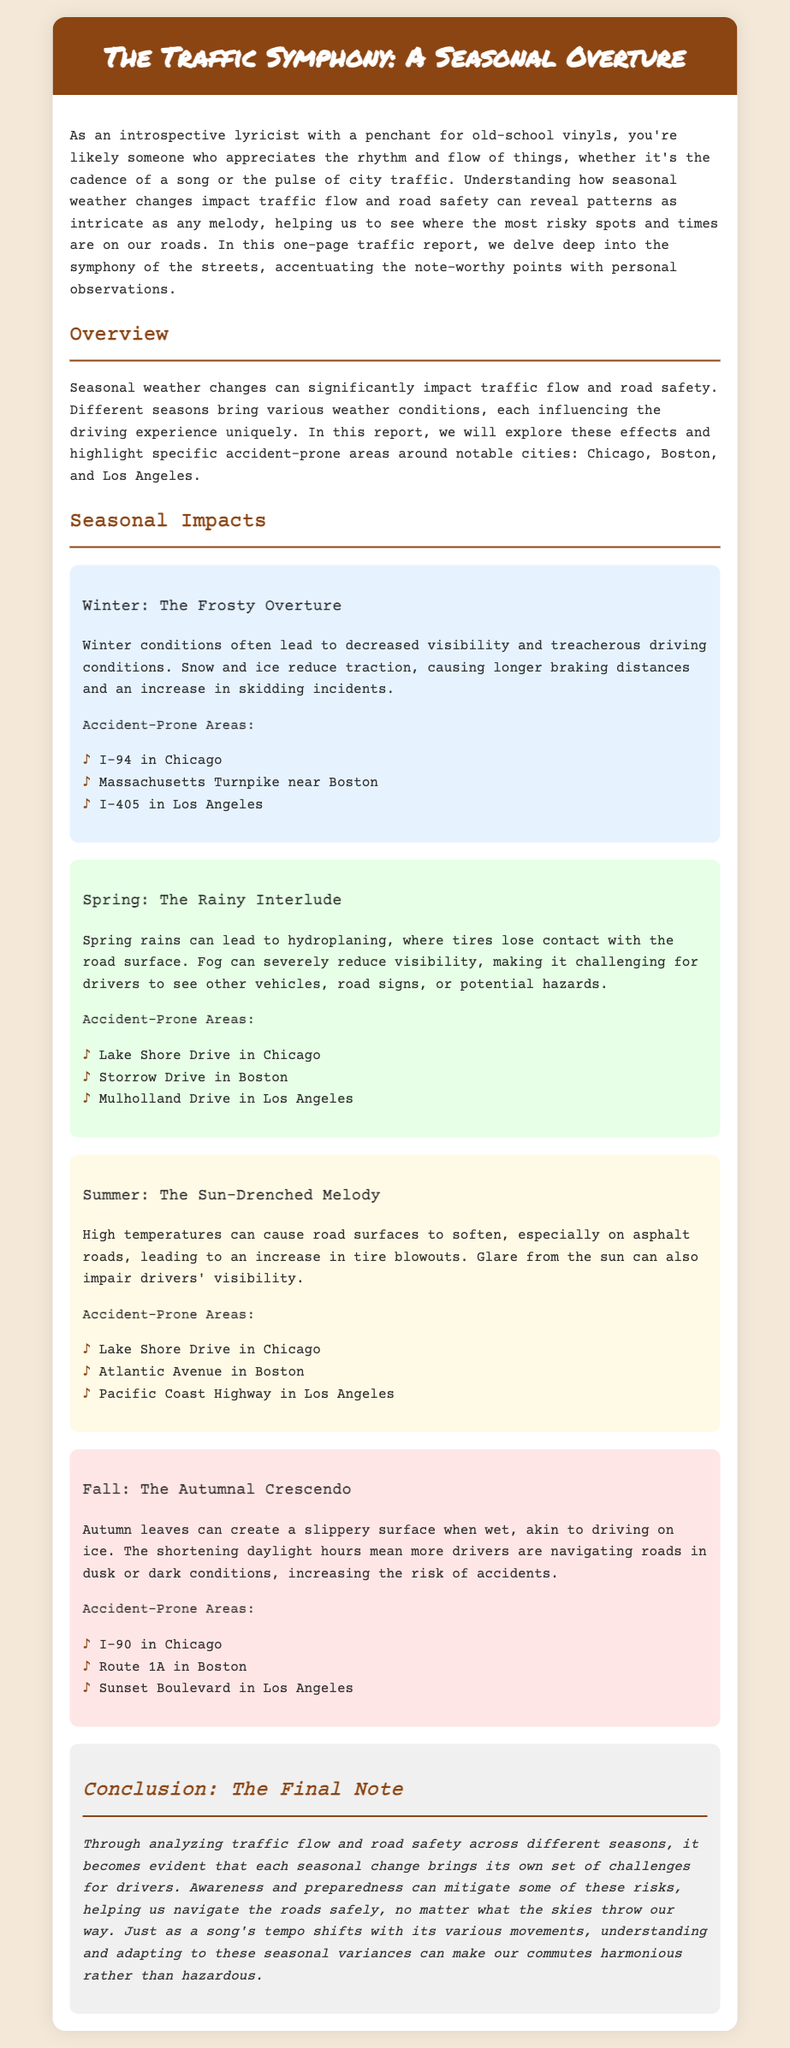what is the title of the report? The title is mentioned in the header of the document.
Answer: The Traffic Symphony: A Seasonal Overture which season is described as "The Frosty Overture"? This season is specifically highlighted in the report under seasonal impacts.
Answer: Winter what is a common hazard during spring that affects driving? The document mentions specific conditions that create driving hazards during spring.
Answer: Hydroplaning name an accident-prone area in Boston during fall. This information is provided under the accident-prone areas in each season section.
Answer: Route 1A how does summer weather affect roads? The report describes specific impacts of summer conditions on road surfaces and driving.
Answer: High temperatures can cause road surfaces to soften what are the two primary risks associated with autumn on the roads? This information can be deduced from the hazards mentioned in the fall season section.
Answer: Slippery surfaces and reduced visibility which accident-prone area is mentioned for Chicago in winter? The report lists accident-prone areas for each season, including for Chicago in winter.
Answer: I-94 in Chicago how does the report suggest mitigating risks during seasonal changes? The conclusion outlines strategies for dealing with seasonal driving challenges.
Answer: Awareness and preparedness 